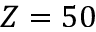Convert formula to latex. <formula><loc_0><loc_0><loc_500><loc_500>Z = 5 0</formula> 